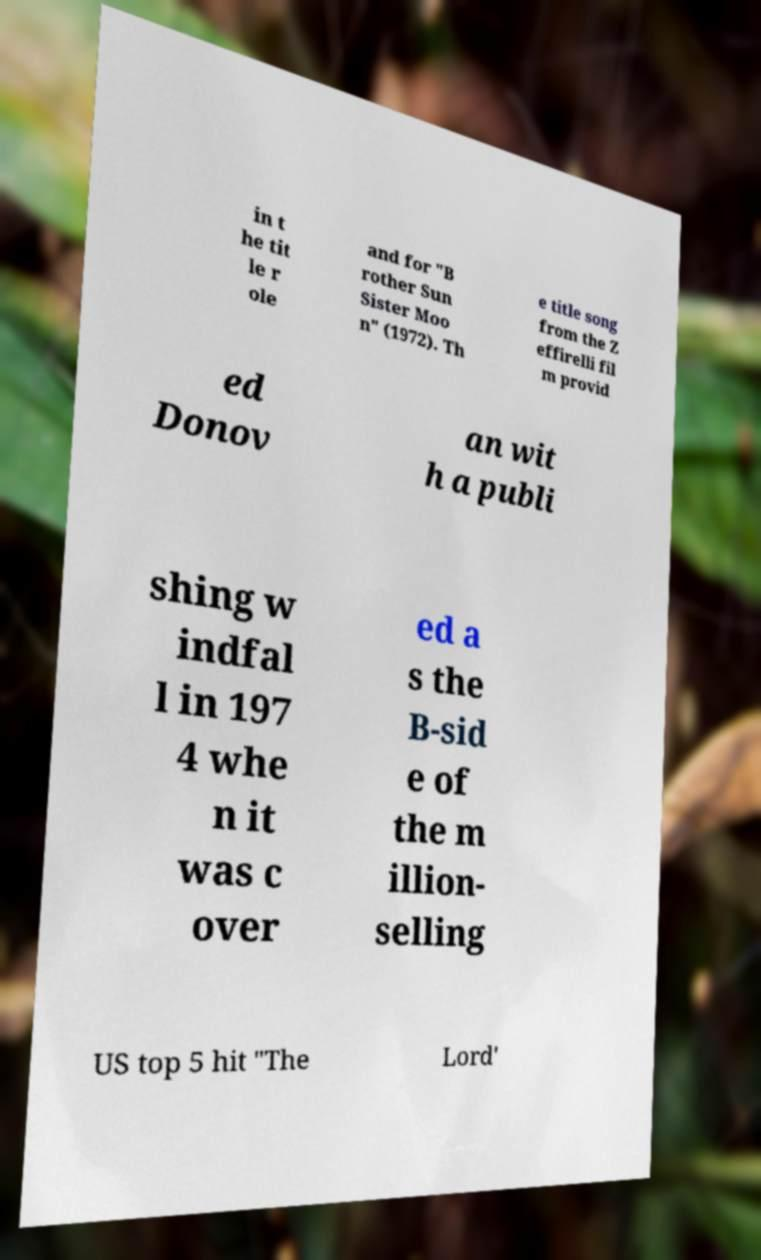For documentation purposes, I need the text within this image transcribed. Could you provide that? in t he tit le r ole and for "B rother Sun Sister Moo n" (1972). Th e title song from the Z effirelli fil m provid ed Donov an wit h a publi shing w indfal l in 197 4 whe n it was c over ed a s the B-sid e of the m illion- selling US top 5 hit "The Lord' 